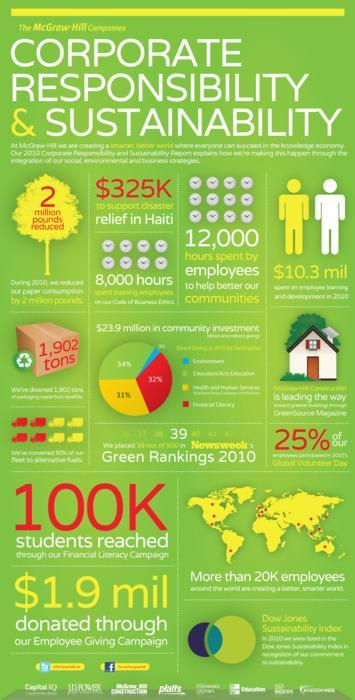What was the amount given as relief to Haiti
Answer the question with a short phrase. $325K How many hours did employees spend for help better communities 12,000 